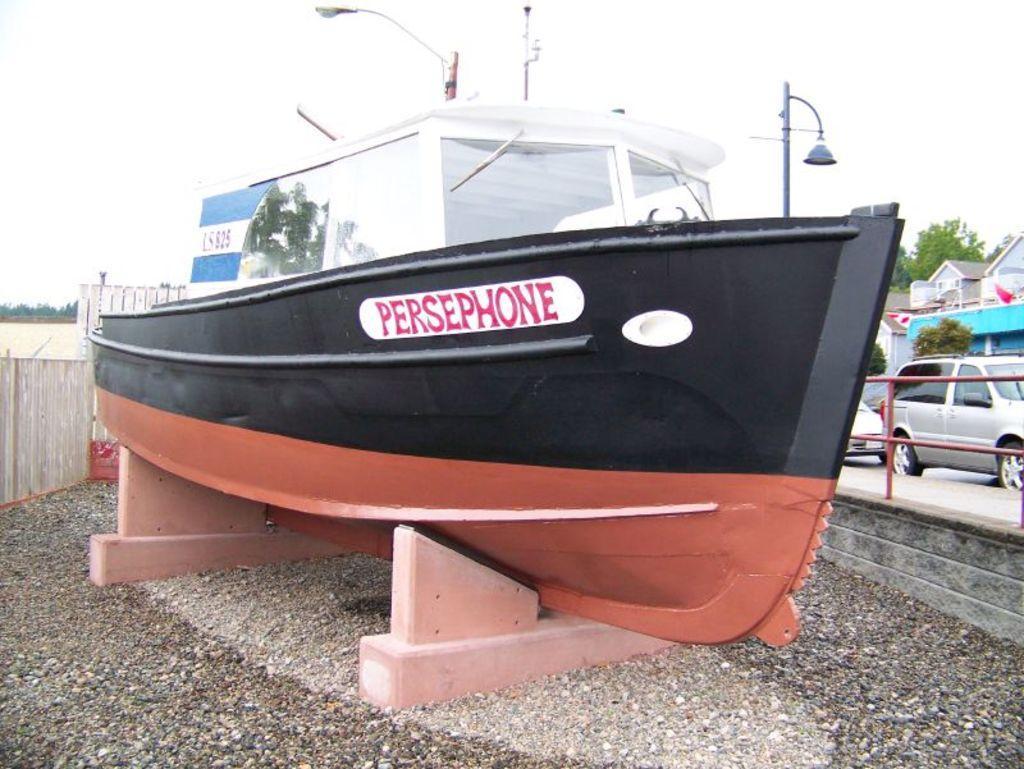Please provide a concise description of this image. In this picture we can see a boat. There are few trees, a building and some fencing on the right side. Greenery is visible in the background. 